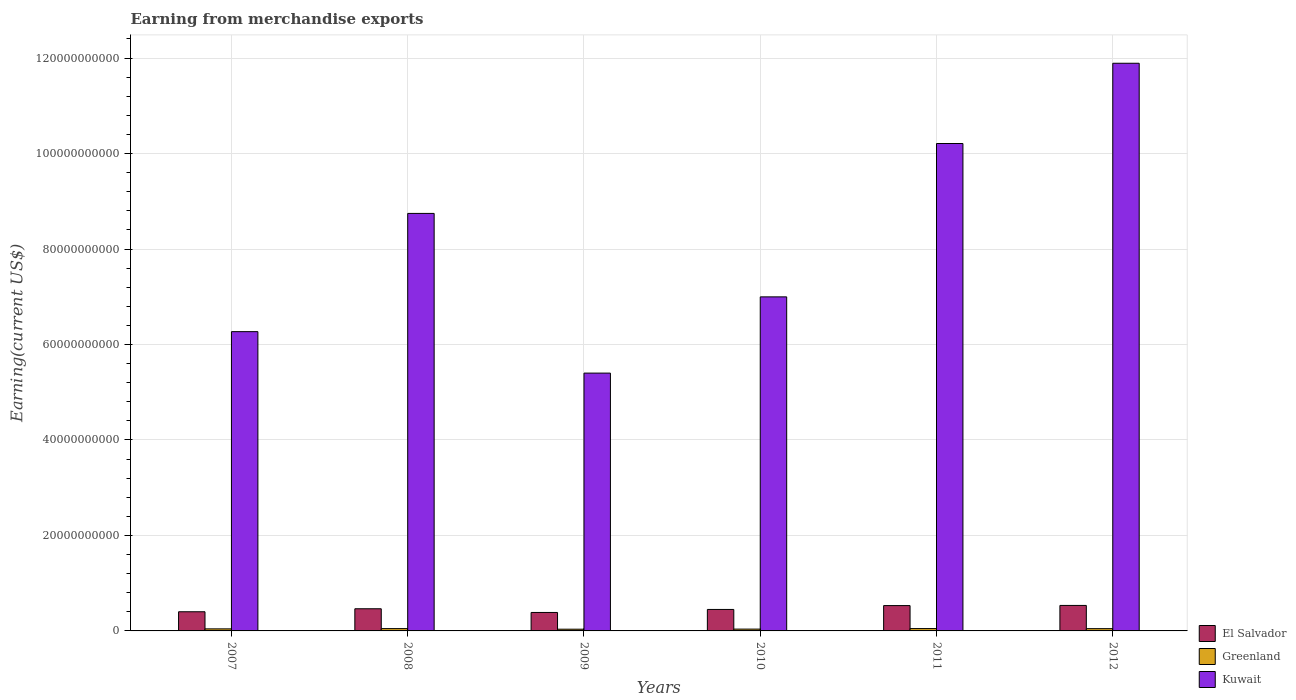How many groups of bars are there?
Make the answer very short. 6. Are the number of bars per tick equal to the number of legend labels?
Offer a terse response. Yes. How many bars are there on the 6th tick from the left?
Offer a terse response. 3. What is the amount earned from merchandise exports in Kuwait in 2011?
Offer a terse response. 1.02e+11. Across all years, what is the maximum amount earned from merchandise exports in Kuwait?
Your answer should be very brief. 1.19e+11. Across all years, what is the minimum amount earned from merchandise exports in Greenland?
Your answer should be compact. 3.60e+08. In which year was the amount earned from merchandise exports in Greenland minimum?
Give a very brief answer. 2009. What is the total amount earned from merchandise exports in Greenland in the graph?
Provide a succinct answer. 2.63e+09. What is the difference between the amount earned from merchandise exports in El Salvador in 2007 and that in 2009?
Provide a succinct answer. 1.48e+08. What is the difference between the amount earned from merchandise exports in Kuwait in 2008 and the amount earned from merchandise exports in El Salvador in 2010?
Your response must be concise. 8.30e+1. What is the average amount earned from merchandise exports in El Salvador per year?
Provide a succinct answer. 4.61e+09. In the year 2012, what is the difference between the amount earned from merchandise exports in El Salvador and amount earned from merchandise exports in Greenland?
Make the answer very short. 4.86e+09. What is the ratio of the amount earned from merchandise exports in El Salvador in 2009 to that in 2010?
Provide a succinct answer. 0.86. Is the difference between the amount earned from merchandise exports in El Salvador in 2008 and 2009 greater than the difference between the amount earned from merchandise exports in Greenland in 2008 and 2009?
Provide a succinct answer. Yes. What is the difference between the highest and the second highest amount earned from merchandise exports in Kuwait?
Make the answer very short. 1.68e+1. What is the difference between the highest and the lowest amount earned from merchandise exports in El Salvador?
Your response must be concise. 1.47e+09. What does the 3rd bar from the left in 2007 represents?
Provide a short and direct response. Kuwait. What does the 2nd bar from the right in 2009 represents?
Offer a terse response. Greenland. Are all the bars in the graph horizontal?
Keep it short and to the point. No. How many years are there in the graph?
Offer a very short reply. 6. Are the values on the major ticks of Y-axis written in scientific E-notation?
Provide a short and direct response. No. Where does the legend appear in the graph?
Give a very brief answer. Bottom right. How are the legend labels stacked?
Your answer should be compact. Vertical. What is the title of the graph?
Your answer should be compact. Earning from merchandise exports. Does "Yemen, Rep." appear as one of the legend labels in the graph?
Give a very brief answer. No. What is the label or title of the Y-axis?
Provide a succinct answer. Earning(current US$). What is the Earning(current US$) in El Salvador in 2007?
Keep it short and to the point. 4.01e+09. What is the Earning(current US$) of Greenland in 2007?
Keep it short and to the point. 4.31e+08. What is the Earning(current US$) of Kuwait in 2007?
Provide a succinct answer. 6.27e+1. What is the Earning(current US$) in El Salvador in 2008?
Your answer should be compact. 4.64e+09. What is the Earning(current US$) of Greenland in 2008?
Keep it short and to the point. 4.87e+08. What is the Earning(current US$) of Kuwait in 2008?
Your answer should be very brief. 8.75e+1. What is the Earning(current US$) in El Salvador in 2009?
Keep it short and to the point. 3.87e+09. What is the Earning(current US$) in Greenland in 2009?
Offer a terse response. 3.60e+08. What is the Earning(current US$) in Kuwait in 2009?
Offer a terse response. 5.40e+1. What is the Earning(current US$) of El Salvador in 2010?
Keep it short and to the point. 4.50e+09. What is the Earning(current US$) in Greenland in 2010?
Make the answer very short. 3.80e+08. What is the Earning(current US$) of Kuwait in 2010?
Offer a terse response. 7.00e+1. What is the Earning(current US$) in El Salvador in 2011?
Give a very brief answer. 5.31e+09. What is the Earning(current US$) of Greenland in 2011?
Provide a short and direct response. 4.91e+08. What is the Earning(current US$) of Kuwait in 2011?
Offer a terse response. 1.02e+11. What is the Earning(current US$) in El Salvador in 2012?
Provide a succinct answer. 5.34e+09. What is the Earning(current US$) in Greenland in 2012?
Provide a succinct answer. 4.75e+08. What is the Earning(current US$) in Kuwait in 2012?
Offer a very short reply. 1.19e+11. Across all years, what is the maximum Earning(current US$) of El Salvador?
Offer a very short reply. 5.34e+09. Across all years, what is the maximum Earning(current US$) of Greenland?
Your response must be concise. 4.91e+08. Across all years, what is the maximum Earning(current US$) of Kuwait?
Your answer should be compact. 1.19e+11. Across all years, what is the minimum Earning(current US$) in El Salvador?
Keep it short and to the point. 3.87e+09. Across all years, what is the minimum Earning(current US$) in Greenland?
Your answer should be very brief. 3.60e+08. Across all years, what is the minimum Earning(current US$) of Kuwait?
Offer a very short reply. 5.40e+1. What is the total Earning(current US$) of El Salvador in the graph?
Provide a short and direct response. 2.77e+1. What is the total Earning(current US$) in Greenland in the graph?
Make the answer very short. 2.63e+09. What is the total Earning(current US$) of Kuwait in the graph?
Provide a short and direct response. 4.95e+11. What is the difference between the Earning(current US$) of El Salvador in 2007 and that in 2008?
Offer a very short reply. -6.27e+08. What is the difference between the Earning(current US$) in Greenland in 2007 and that in 2008?
Offer a terse response. -5.65e+07. What is the difference between the Earning(current US$) of Kuwait in 2007 and that in 2008?
Keep it short and to the point. -2.48e+1. What is the difference between the Earning(current US$) in El Salvador in 2007 and that in 2009?
Your answer should be very brief. 1.48e+08. What is the difference between the Earning(current US$) of Greenland in 2007 and that in 2009?
Offer a terse response. 7.10e+07. What is the difference between the Earning(current US$) of Kuwait in 2007 and that in 2009?
Your response must be concise. 8.68e+09. What is the difference between the Earning(current US$) in El Salvador in 2007 and that in 2010?
Offer a terse response. -4.85e+08. What is the difference between the Earning(current US$) in Greenland in 2007 and that in 2010?
Your answer should be very brief. 5.09e+07. What is the difference between the Earning(current US$) of Kuwait in 2007 and that in 2010?
Your response must be concise. -7.29e+09. What is the difference between the Earning(current US$) in El Salvador in 2007 and that in 2011?
Make the answer very short. -1.29e+09. What is the difference between the Earning(current US$) in Greenland in 2007 and that in 2011?
Your answer should be very brief. -6.04e+07. What is the difference between the Earning(current US$) of Kuwait in 2007 and that in 2011?
Ensure brevity in your answer.  -3.94e+1. What is the difference between the Earning(current US$) of El Salvador in 2007 and that in 2012?
Give a very brief answer. -1.32e+09. What is the difference between the Earning(current US$) of Greenland in 2007 and that in 2012?
Give a very brief answer. -4.45e+07. What is the difference between the Earning(current US$) in Kuwait in 2007 and that in 2012?
Your answer should be compact. -5.62e+1. What is the difference between the Earning(current US$) in El Salvador in 2008 and that in 2009?
Provide a short and direct response. 7.75e+08. What is the difference between the Earning(current US$) of Greenland in 2008 and that in 2009?
Offer a terse response. 1.27e+08. What is the difference between the Earning(current US$) of Kuwait in 2008 and that in 2009?
Give a very brief answer. 3.34e+1. What is the difference between the Earning(current US$) of El Salvador in 2008 and that in 2010?
Give a very brief answer. 1.42e+08. What is the difference between the Earning(current US$) in Greenland in 2008 and that in 2010?
Give a very brief answer. 1.07e+08. What is the difference between the Earning(current US$) of Kuwait in 2008 and that in 2010?
Your response must be concise. 1.75e+1. What is the difference between the Earning(current US$) in El Salvador in 2008 and that in 2011?
Give a very brief answer. -6.67e+08. What is the difference between the Earning(current US$) in Greenland in 2008 and that in 2011?
Offer a terse response. -3.88e+06. What is the difference between the Earning(current US$) of Kuwait in 2008 and that in 2011?
Your response must be concise. -1.46e+1. What is the difference between the Earning(current US$) in El Salvador in 2008 and that in 2012?
Keep it short and to the point. -6.98e+08. What is the difference between the Earning(current US$) of Greenland in 2008 and that in 2012?
Provide a short and direct response. 1.20e+07. What is the difference between the Earning(current US$) in Kuwait in 2008 and that in 2012?
Make the answer very short. -3.15e+1. What is the difference between the Earning(current US$) of El Salvador in 2009 and that in 2010?
Your answer should be very brief. -6.33e+08. What is the difference between the Earning(current US$) in Greenland in 2009 and that in 2010?
Offer a very short reply. -2.00e+07. What is the difference between the Earning(current US$) of Kuwait in 2009 and that in 2010?
Provide a short and direct response. -1.60e+1. What is the difference between the Earning(current US$) of El Salvador in 2009 and that in 2011?
Your response must be concise. -1.44e+09. What is the difference between the Earning(current US$) of Greenland in 2009 and that in 2011?
Offer a very short reply. -1.31e+08. What is the difference between the Earning(current US$) in Kuwait in 2009 and that in 2011?
Provide a succinct answer. -4.81e+1. What is the difference between the Earning(current US$) in El Salvador in 2009 and that in 2012?
Give a very brief answer. -1.47e+09. What is the difference between the Earning(current US$) of Greenland in 2009 and that in 2012?
Offer a terse response. -1.15e+08. What is the difference between the Earning(current US$) in Kuwait in 2009 and that in 2012?
Ensure brevity in your answer.  -6.49e+1. What is the difference between the Earning(current US$) of El Salvador in 2010 and that in 2011?
Your answer should be compact. -8.09e+08. What is the difference between the Earning(current US$) of Greenland in 2010 and that in 2011?
Give a very brief answer. -1.11e+08. What is the difference between the Earning(current US$) of Kuwait in 2010 and that in 2011?
Offer a very short reply. -3.21e+1. What is the difference between the Earning(current US$) of El Salvador in 2010 and that in 2012?
Your answer should be very brief. -8.40e+08. What is the difference between the Earning(current US$) in Greenland in 2010 and that in 2012?
Ensure brevity in your answer.  -9.54e+07. What is the difference between the Earning(current US$) in Kuwait in 2010 and that in 2012?
Your answer should be compact. -4.89e+1. What is the difference between the Earning(current US$) of El Salvador in 2011 and that in 2012?
Ensure brevity in your answer.  -3.08e+07. What is the difference between the Earning(current US$) of Greenland in 2011 and that in 2012?
Make the answer very short. 1.59e+07. What is the difference between the Earning(current US$) in Kuwait in 2011 and that in 2012?
Offer a very short reply. -1.68e+1. What is the difference between the Earning(current US$) in El Salvador in 2007 and the Earning(current US$) in Greenland in 2008?
Make the answer very short. 3.53e+09. What is the difference between the Earning(current US$) of El Salvador in 2007 and the Earning(current US$) of Kuwait in 2008?
Keep it short and to the point. -8.34e+1. What is the difference between the Earning(current US$) of Greenland in 2007 and the Earning(current US$) of Kuwait in 2008?
Your response must be concise. -8.70e+1. What is the difference between the Earning(current US$) of El Salvador in 2007 and the Earning(current US$) of Greenland in 2009?
Ensure brevity in your answer.  3.65e+09. What is the difference between the Earning(current US$) in El Salvador in 2007 and the Earning(current US$) in Kuwait in 2009?
Make the answer very short. -5.00e+1. What is the difference between the Earning(current US$) of Greenland in 2007 and the Earning(current US$) of Kuwait in 2009?
Provide a short and direct response. -5.36e+1. What is the difference between the Earning(current US$) in El Salvador in 2007 and the Earning(current US$) in Greenland in 2010?
Provide a short and direct response. 3.63e+09. What is the difference between the Earning(current US$) of El Salvador in 2007 and the Earning(current US$) of Kuwait in 2010?
Offer a terse response. -6.60e+1. What is the difference between the Earning(current US$) of Greenland in 2007 and the Earning(current US$) of Kuwait in 2010?
Your answer should be very brief. -6.95e+1. What is the difference between the Earning(current US$) in El Salvador in 2007 and the Earning(current US$) in Greenland in 2011?
Provide a succinct answer. 3.52e+09. What is the difference between the Earning(current US$) in El Salvador in 2007 and the Earning(current US$) in Kuwait in 2011?
Make the answer very short. -9.81e+1. What is the difference between the Earning(current US$) in Greenland in 2007 and the Earning(current US$) in Kuwait in 2011?
Your answer should be very brief. -1.02e+11. What is the difference between the Earning(current US$) of El Salvador in 2007 and the Earning(current US$) of Greenland in 2012?
Provide a succinct answer. 3.54e+09. What is the difference between the Earning(current US$) of El Salvador in 2007 and the Earning(current US$) of Kuwait in 2012?
Give a very brief answer. -1.15e+11. What is the difference between the Earning(current US$) in Greenland in 2007 and the Earning(current US$) in Kuwait in 2012?
Your answer should be very brief. -1.18e+11. What is the difference between the Earning(current US$) in El Salvador in 2008 and the Earning(current US$) in Greenland in 2009?
Give a very brief answer. 4.28e+09. What is the difference between the Earning(current US$) in El Salvador in 2008 and the Earning(current US$) in Kuwait in 2009?
Give a very brief answer. -4.94e+1. What is the difference between the Earning(current US$) in Greenland in 2008 and the Earning(current US$) in Kuwait in 2009?
Your answer should be compact. -5.35e+1. What is the difference between the Earning(current US$) in El Salvador in 2008 and the Earning(current US$) in Greenland in 2010?
Provide a succinct answer. 4.26e+09. What is the difference between the Earning(current US$) in El Salvador in 2008 and the Earning(current US$) in Kuwait in 2010?
Provide a short and direct response. -6.53e+1. What is the difference between the Earning(current US$) of Greenland in 2008 and the Earning(current US$) of Kuwait in 2010?
Make the answer very short. -6.95e+1. What is the difference between the Earning(current US$) in El Salvador in 2008 and the Earning(current US$) in Greenland in 2011?
Keep it short and to the point. 4.15e+09. What is the difference between the Earning(current US$) in El Salvador in 2008 and the Earning(current US$) in Kuwait in 2011?
Provide a succinct answer. -9.75e+1. What is the difference between the Earning(current US$) of Greenland in 2008 and the Earning(current US$) of Kuwait in 2011?
Offer a very short reply. -1.02e+11. What is the difference between the Earning(current US$) in El Salvador in 2008 and the Earning(current US$) in Greenland in 2012?
Your answer should be compact. 4.17e+09. What is the difference between the Earning(current US$) of El Salvador in 2008 and the Earning(current US$) of Kuwait in 2012?
Offer a very short reply. -1.14e+11. What is the difference between the Earning(current US$) in Greenland in 2008 and the Earning(current US$) in Kuwait in 2012?
Provide a succinct answer. -1.18e+11. What is the difference between the Earning(current US$) in El Salvador in 2009 and the Earning(current US$) in Greenland in 2010?
Your response must be concise. 3.49e+09. What is the difference between the Earning(current US$) in El Salvador in 2009 and the Earning(current US$) in Kuwait in 2010?
Your response must be concise. -6.61e+1. What is the difference between the Earning(current US$) of Greenland in 2009 and the Earning(current US$) of Kuwait in 2010?
Your answer should be very brief. -6.96e+1. What is the difference between the Earning(current US$) of El Salvador in 2009 and the Earning(current US$) of Greenland in 2011?
Offer a terse response. 3.37e+09. What is the difference between the Earning(current US$) in El Salvador in 2009 and the Earning(current US$) in Kuwait in 2011?
Give a very brief answer. -9.82e+1. What is the difference between the Earning(current US$) of Greenland in 2009 and the Earning(current US$) of Kuwait in 2011?
Make the answer very short. -1.02e+11. What is the difference between the Earning(current US$) in El Salvador in 2009 and the Earning(current US$) in Greenland in 2012?
Provide a succinct answer. 3.39e+09. What is the difference between the Earning(current US$) in El Salvador in 2009 and the Earning(current US$) in Kuwait in 2012?
Give a very brief answer. -1.15e+11. What is the difference between the Earning(current US$) of Greenland in 2009 and the Earning(current US$) of Kuwait in 2012?
Your answer should be compact. -1.19e+11. What is the difference between the Earning(current US$) in El Salvador in 2010 and the Earning(current US$) in Greenland in 2011?
Make the answer very short. 4.01e+09. What is the difference between the Earning(current US$) of El Salvador in 2010 and the Earning(current US$) of Kuwait in 2011?
Offer a terse response. -9.76e+1. What is the difference between the Earning(current US$) of Greenland in 2010 and the Earning(current US$) of Kuwait in 2011?
Your response must be concise. -1.02e+11. What is the difference between the Earning(current US$) of El Salvador in 2010 and the Earning(current US$) of Greenland in 2012?
Keep it short and to the point. 4.02e+09. What is the difference between the Earning(current US$) of El Salvador in 2010 and the Earning(current US$) of Kuwait in 2012?
Provide a succinct answer. -1.14e+11. What is the difference between the Earning(current US$) of Greenland in 2010 and the Earning(current US$) of Kuwait in 2012?
Offer a terse response. -1.19e+11. What is the difference between the Earning(current US$) of El Salvador in 2011 and the Earning(current US$) of Greenland in 2012?
Your answer should be very brief. 4.83e+09. What is the difference between the Earning(current US$) in El Salvador in 2011 and the Earning(current US$) in Kuwait in 2012?
Keep it short and to the point. -1.14e+11. What is the difference between the Earning(current US$) in Greenland in 2011 and the Earning(current US$) in Kuwait in 2012?
Provide a short and direct response. -1.18e+11. What is the average Earning(current US$) of El Salvador per year?
Make the answer very short. 4.61e+09. What is the average Earning(current US$) in Greenland per year?
Ensure brevity in your answer.  4.38e+08. What is the average Earning(current US$) of Kuwait per year?
Make the answer very short. 8.25e+1. In the year 2007, what is the difference between the Earning(current US$) in El Salvador and Earning(current US$) in Greenland?
Make the answer very short. 3.58e+09. In the year 2007, what is the difference between the Earning(current US$) of El Salvador and Earning(current US$) of Kuwait?
Your response must be concise. -5.87e+1. In the year 2007, what is the difference between the Earning(current US$) of Greenland and Earning(current US$) of Kuwait?
Offer a very short reply. -6.23e+1. In the year 2008, what is the difference between the Earning(current US$) of El Salvador and Earning(current US$) of Greenland?
Give a very brief answer. 4.15e+09. In the year 2008, what is the difference between the Earning(current US$) of El Salvador and Earning(current US$) of Kuwait?
Your response must be concise. -8.28e+1. In the year 2008, what is the difference between the Earning(current US$) of Greenland and Earning(current US$) of Kuwait?
Offer a terse response. -8.70e+1. In the year 2009, what is the difference between the Earning(current US$) in El Salvador and Earning(current US$) in Greenland?
Your answer should be very brief. 3.51e+09. In the year 2009, what is the difference between the Earning(current US$) in El Salvador and Earning(current US$) in Kuwait?
Make the answer very short. -5.01e+1. In the year 2009, what is the difference between the Earning(current US$) in Greenland and Earning(current US$) in Kuwait?
Ensure brevity in your answer.  -5.36e+1. In the year 2010, what is the difference between the Earning(current US$) in El Salvador and Earning(current US$) in Greenland?
Your response must be concise. 4.12e+09. In the year 2010, what is the difference between the Earning(current US$) of El Salvador and Earning(current US$) of Kuwait?
Offer a terse response. -6.55e+1. In the year 2010, what is the difference between the Earning(current US$) of Greenland and Earning(current US$) of Kuwait?
Give a very brief answer. -6.96e+1. In the year 2011, what is the difference between the Earning(current US$) of El Salvador and Earning(current US$) of Greenland?
Offer a terse response. 4.82e+09. In the year 2011, what is the difference between the Earning(current US$) of El Salvador and Earning(current US$) of Kuwait?
Ensure brevity in your answer.  -9.68e+1. In the year 2011, what is the difference between the Earning(current US$) in Greenland and Earning(current US$) in Kuwait?
Your answer should be compact. -1.02e+11. In the year 2012, what is the difference between the Earning(current US$) of El Salvador and Earning(current US$) of Greenland?
Your answer should be compact. 4.86e+09. In the year 2012, what is the difference between the Earning(current US$) in El Salvador and Earning(current US$) in Kuwait?
Provide a succinct answer. -1.14e+11. In the year 2012, what is the difference between the Earning(current US$) of Greenland and Earning(current US$) of Kuwait?
Provide a succinct answer. -1.18e+11. What is the ratio of the Earning(current US$) of El Salvador in 2007 to that in 2008?
Make the answer very short. 0.86. What is the ratio of the Earning(current US$) of Greenland in 2007 to that in 2008?
Your answer should be compact. 0.88. What is the ratio of the Earning(current US$) in Kuwait in 2007 to that in 2008?
Make the answer very short. 0.72. What is the ratio of the Earning(current US$) in El Salvador in 2007 to that in 2009?
Offer a terse response. 1.04. What is the ratio of the Earning(current US$) of Greenland in 2007 to that in 2009?
Provide a succinct answer. 1.2. What is the ratio of the Earning(current US$) in Kuwait in 2007 to that in 2009?
Your answer should be very brief. 1.16. What is the ratio of the Earning(current US$) of El Salvador in 2007 to that in 2010?
Make the answer very short. 0.89. What is the ratio of the Earning(current US$) of Greenland in 2007 to that in 2010?
Keep it short and to the point. 1.13. What is the ratio of the Earning(current US$) of Kuwait in 2007 to that in 2010?
Make the answer very short. 0.9. What is the ratio of the Earning(current US$) of El Salvador in 2007 to that in 2011?
Offer a very short reply. 0.76. What is the ratio of the Earning(current US$) of Greenland in 2007 to that in 2011?
Offer a very short reply. 0.88. What is the ratio of the Earning(current US$) of Kuwait in 2007 to that in 2011?
Make the answer very short. 0.61. What is the ratio of the Earning(current US$) of El Salvador in 2007 to that in 2012?
Offer a very short reply. 0.75. What is the ratio of the Earning(current US$) in Greenland in 2007 to that in 2012?
Offer a very short reply. 0.91. What is the ratio of the Earning(current US$) of Kuwait in 2007 to that in 2012?
Keep it short and to the point. 0.53. What is the ratio of the Earning(current US$) of El Salvador in 2008 to that in 2009?
Offer a terse response. 1.2. What is the ratio of the Earning(current US$) in Greenland in 2008 to that in 2009?
Keep it short and to the point. 1.35. What is the ratio of the Earning(current US$) of Kuwait in 2008 to that in 2009?
Keep it short and to the point. 1.62. What is the ratio of the Earning(current US$) of El Salvador in 2008 to that in 2010?
Provide a short and direct response. 1.03. What is the ratio of the Earning(current US$) of Greenland in 2008 to that in 2010?
Make the answer very short. 1.28. What is the ratio of the Earning(current US$) in Kuwait in 2008 to that in 2010?
Your answer should be very brief. 1.25. What is the ratio of the Earning(current US$) in El Salvador in 2008 to that in 2011?
Make the answer very short. 0.87. What is the ratio of the Earning(current US$) in Greenland in 2008 to that in 2011?
Offer a very short reply. 0.99. What is the ratio of the Earning(current US$) of Kuwait in 2008 to that in 2011?
Offer a very short reply. 0.86. What is the ratio of the Earning(current US$) of El Salvador in 2008 to that in 2012?
Offer a very short reply. 0.87. What is the ratio of the Earning(current US$) of Greenland in 2008 to that in 2012?
Offer a terse response. 1.03. What is the ratio of the Earning(current US$) of Kuwait in 2008 to that in 2012?
Your response must be concise. 0.74. What is the ratio of the Earning(current US$) in El Salvador in 2009 to that in 2010?
Ensure brevity in your answer.  0.86. What is the ratio of the Earning(current US$) of Greenland in 2009 to that in 2010?
Offer a terse response. 0.95. What is the ratio of the Earning(current US$) in Kuwait in 2009 to that in 2010?
Offer a very short reply. 0.77. What is the ratio of the Earning(current US$) of El Salvador in 2009 to that in 2011?
Make the answer very short. 0.73. What is the ratio of the Earning(current US$) in Greenland in 2009 to that in 2011?
Provide a succinct answer. 0.73. What is the ratio of the Earning(current US$) of Kuwait in 2009 to that in 2011?
Ensure brevity in your answer.  0.53. What is the ratio of the Earning(current US$) of El Salvador in 2009 to that in 2012?
Provide a short and direct response. 0.72. What is the ratio of the Earning(current US$) in Greenland in 2009 to that in 2012?
Keep it short and to the point. 0.76. What is the ratio of the Earning(current US$) in Kuwait in 2009 to that in 2012?
Ensure brevity in your answer.  0.45. What is the ratio of the Earning(current US$) of El Salvador in 2010 to that in 2011?
Your answer should be compact. 0.85. What is the ratio of the Earning(current US$) in Greenland in 2010 to that in 2011?
Your answer should be compact. 0.77. What is the ratio of the Earning(current US$) in Kuwait in 2010 to that in 2011?
Keep it short and to the point. 0.69. What is the ratio of the Earning(current US$) in El Salvador in 2010 to that in 2012?
Give a very brief answer. 0.84. What is the ratio of the Earning(current US$) of Greenland in 2010 to that in 2012?
Offer a terse response. 0.8. What is the ratio of the Earning(current US$) in Kuwait in 2010 to that in 2012?
Your answer should be compact. 0.59. What is the ratio of the Earning(current US$) of Greenland in 2011 to that in 2012?
Give a very brief answer. 1.03. What is the ratio of the Earning(current US$) of Kuwait in 2011 to that in 2012?
Make the answer very short. 0.86. What is the difference between the highest and the second highest Earning(current US$) in El Salvador?
Offer a very short reply. 3.08e+07. What is the difference between the highest and the second highest Earning(current US$) of Greenland?
Give a very brief answer. 3.88e+06. What is the difference between the highest and the second highest Earning(current US$) in Kuwait?
Keep it short and to the point. 1.68e+1. What is the difference between the highest and the lowest Earning(current US$) of El Salvador?
Your answer should be very brief. 1.47e+09. What is the difference between the highest and the lowest Earning(current US$) in Greenland?
Your response must be concise. 1.31e+08. What is the difference between the highest and the lowest Earning(current US$) in Kuwait?
Provide a succinct answer. 6.49e+1. 